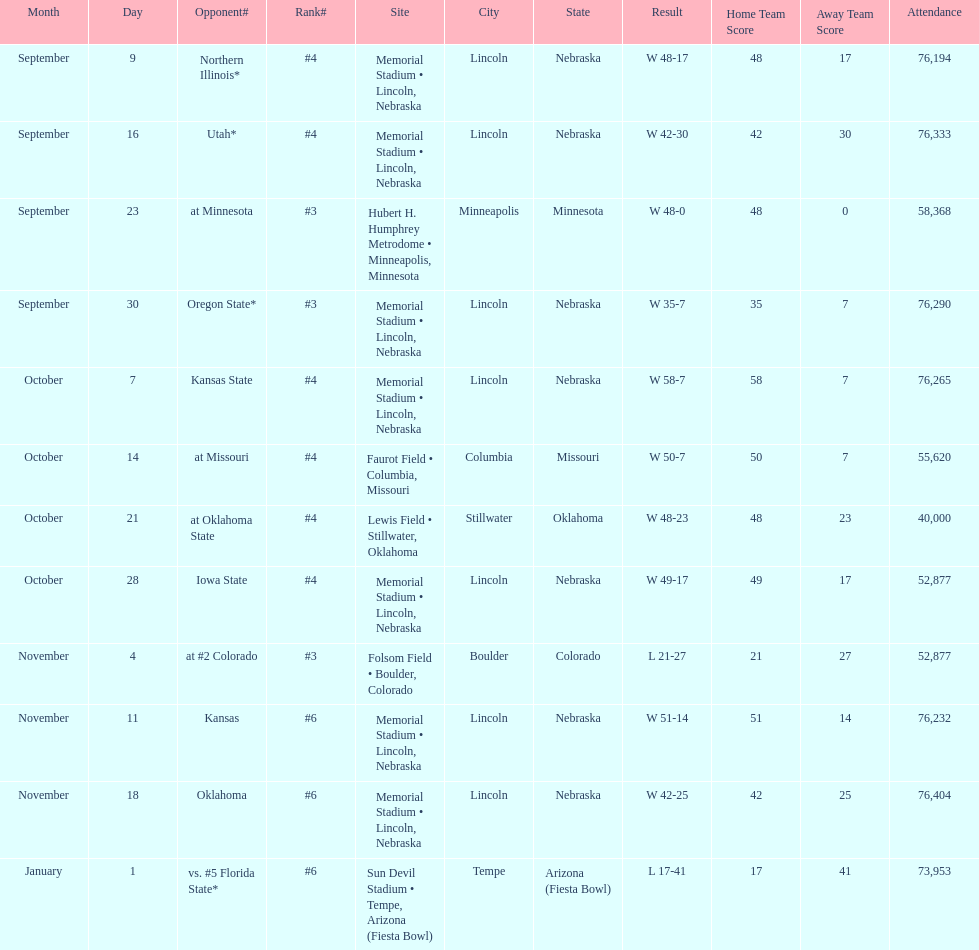How many games was their ranking not lower than #5? 9. 